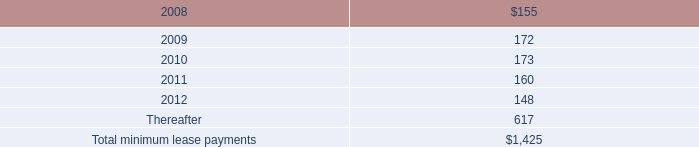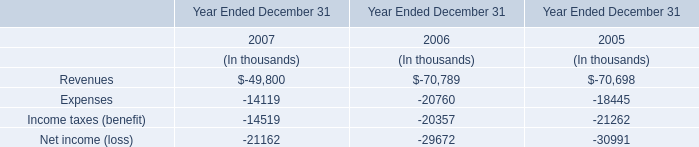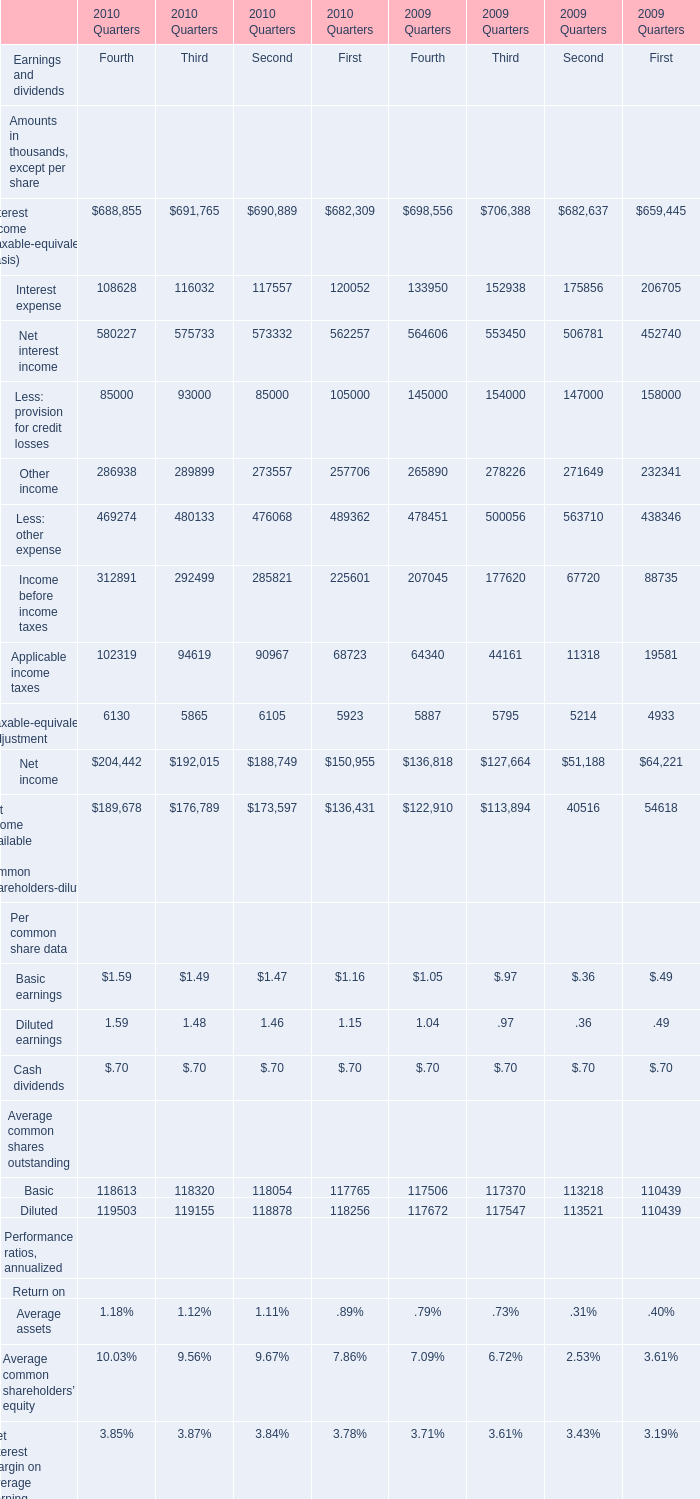At end of quarter what of 2010 does Earning assets reach the largest value? 
Answer: 1. 